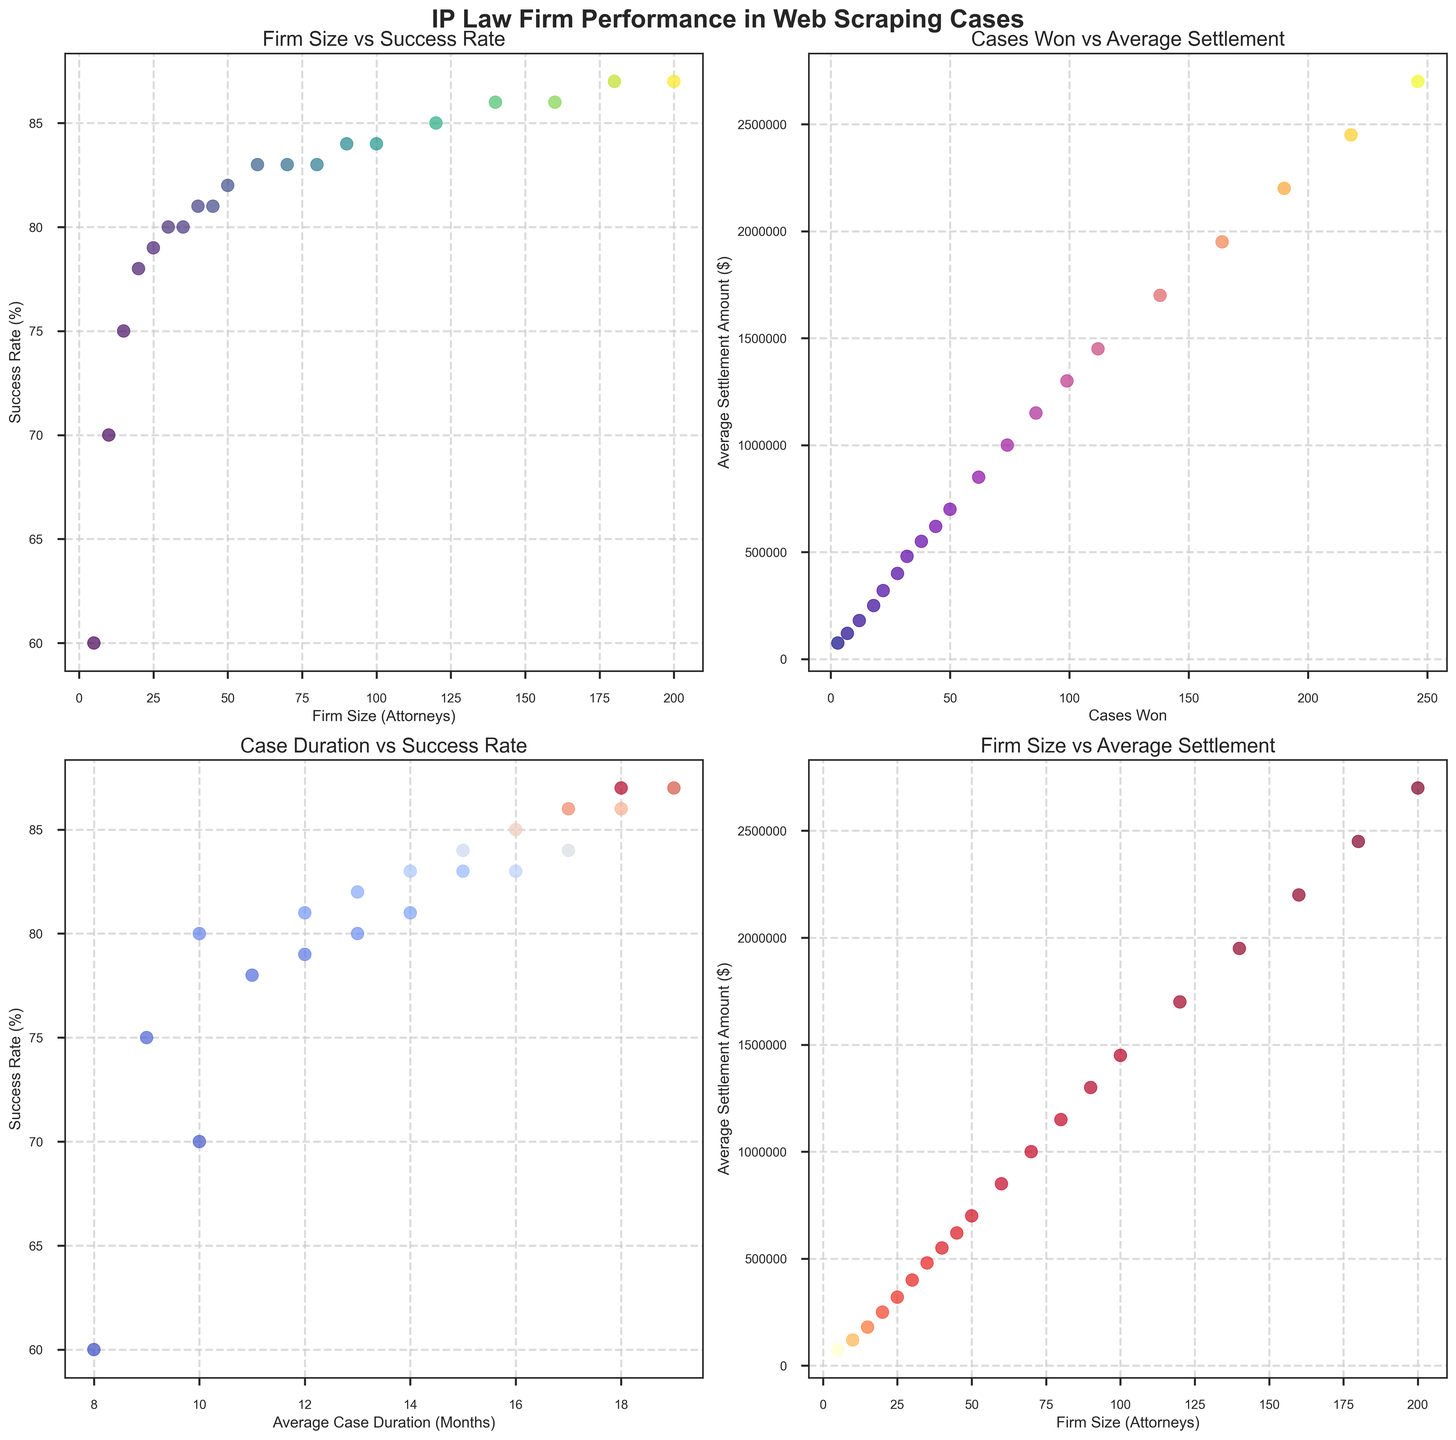What is the relationship between firm size and success rate? By examining the scatter plot labeled "Firm Size vs Success Rate," there is a general upward trend, indicating that as the firm size increases, the success rate tends to increase as well.
Answer: Positive correlation Does a higher number of cases won correlate with a higher average settlement amount? In the scatter plot "Cases Won vs Average Settlement," there is a positive correlation. As the number of cases won increases, the average settlement amount also increases.
Answer: Yes Is there a notable relationship between the average case duration and the success rate? From the scatter plot "Case Duration vs Success Rate," there is no clear trend showing a relationship between average case duration and success rate. The success rate remains relatively stable across different durations.
Answer: No clear relationship Which firm size has the highest success rate? By examining the scatter plot "Firm Size vs Success Rate," the highest success rate is observed at the firm size of 200 attorneys, with a success rate of 87%.
Answer: 200 attorneys In which firm size range does the average settlement amount reach $1,000,000? In the scatter plot "Firm Size vs Average Settlement Amount," the average settlement amount reaches $1,000,000 at a firm size of 70 attorneys.
Answer: 70 attorneys How does the average settlement amount change as the firm size increases from 5 to 200 attorneys? From the scatter plot "Firm Size vs Average Settlement Amount," as the firm size increases from 5 to 200 attorneys, the average settlement amount increases significantly from $75,000 to $2,700,000.
Answer: Increases significantly Compare the success rate at an average case duration of 8 months to that at 18 months. From the scatter plot "Case Duration vs Success Rate," the success rate is around 60% at an 8-month duration and around 87% at an 18-month duration.
Answer: Higher at 18 months What can be inferred about the color coding in the "Firm Size vs Success Rate" plot? In the "Firm Size vs Success Rate" plot, the color coding represents different average settlement amounts, where darker shades indicate higher settlement amounts. As the firm size increases, both success rate and settlement amount tend to be higher.
Answer: Represents settlement amounts Which plot shows the relationship between cases won and average settlement amount? The second scatter plot labeled "Cases Won vs Average Settlement" directly shows the relationship between these two variables.
Answer: Second plot 